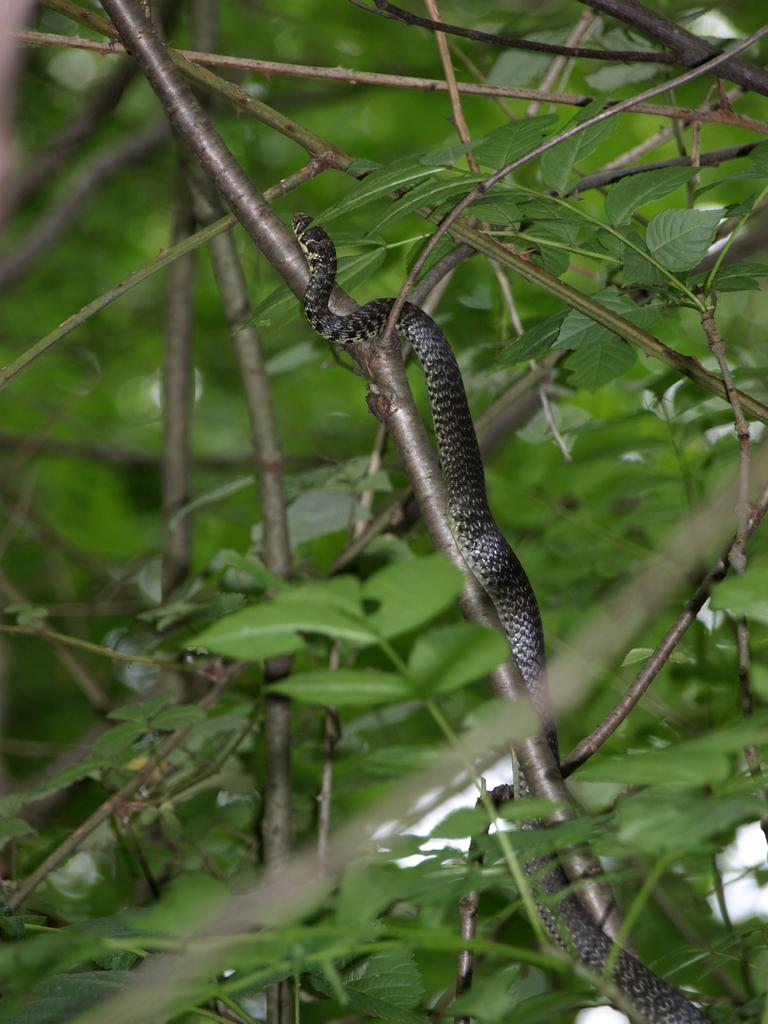What is the main subject in the foreground of the image? There is a snake in the foreground of the image. Where is the snake located? The snake is on a stem. What can be seen around the snake in the image? There are leaves and stems surrounding the snake. How many horses are visible in the image? There are no horses present in the image; it features a snake on a stem surrounded by leaves and stems. 